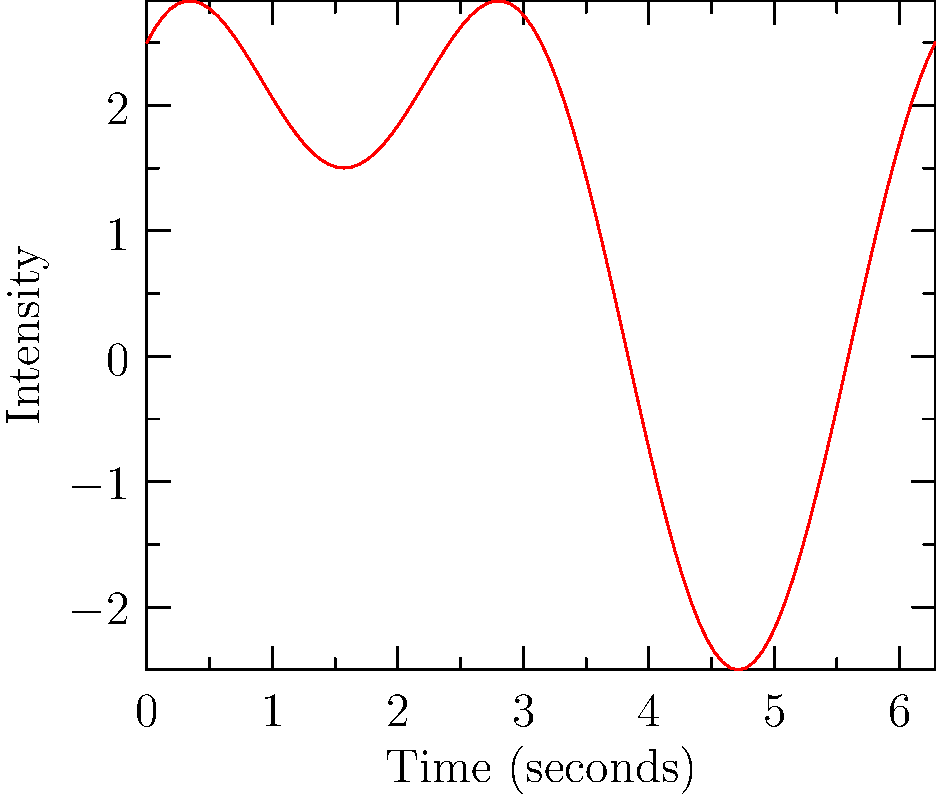A rare musical piece in your partner's collection has an intensity waveform represented by the function $f(t) = 2\sin(t) + 1.5\cos(2t) + 1$, where $t$ is time in seconds and $f(t)$ is the intensity. Calculate the total intensity (area under the curve) between points A and B, which occur at $t = \frac{\pi}{2}$ and $t = \frac{3\pi}{2}$ respectively. To find the area under the curve, we need to integrate the function $f(t)$ from $t = \frac{\pi}{2}$ to $t = \frac{3\pi}{2}$. Let's break this down step-by-step:

1) The integral we need to evaluate is:

   $$\int_{\frac{\pi}{2}}^{\frac{3\pi}{2}} (2\sin(t) + 1.5\cos(2t) + 1) dt$$

2) Let's integrate each term separately:

   a) $\int 2\sin(t) dt = -2\cos(t) + C$
   b) $\int 1.5\cos(2t) dt = \frac{1.5}{2}\sin(2t) + C = 0.75\sin(2t) + C$
   c) $\int 1 dt = t + C$

3) Now, let's apply the fundamental theorem of calculus:

   $$[-2\cos(t) + 0.75\sin(2t) + t]_{\frac{\pi}{2}}^{\frac{3\pi}{2}}$$

4) Evaluate at the upper and lower bounds:

   At $t = \frac{3\pi}{2}$: $[-2\cos(\frac{3\pi}{2}) + 0.75\sin(3\pi) + \frac{3\pi}{2}] = [0 + 0 + \frac{3\pi}{2}] = \frac{3\pi}{2}$

   At $t = \frac{\pi}{2}$: $[-2\cos(\frac{\pi}{2}) + 0.75\sin(\pi) + \frac{\pi}{2}] = [0 + 0 + \frac{\pi}{2}] = \frac{\pi}{2}$

5) Subtract the lower bound from the upper bound:

   $$\frac{3\pi}{2} - \frac{\pi}{2} = \pi$$

Therefore, the total intensity (area under the curve) between points A and B is $\pi$.
Answer: $\pi$ 